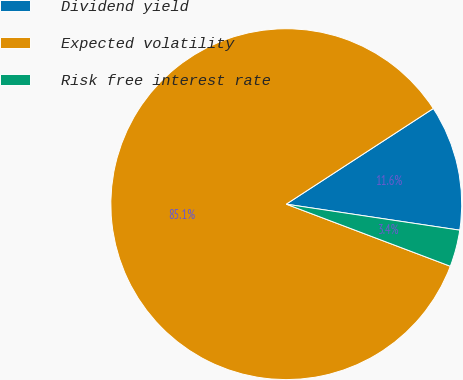<chart> <loc_0><loc_0><loc_500><loc_500><pie_chart><fcel>Dividend yield<fcel>Expected volatility<fcel>Risk free interest rate<nl><fcel>11.55%<fcel>85.06%<fcel>3.39%<nl></chart> 